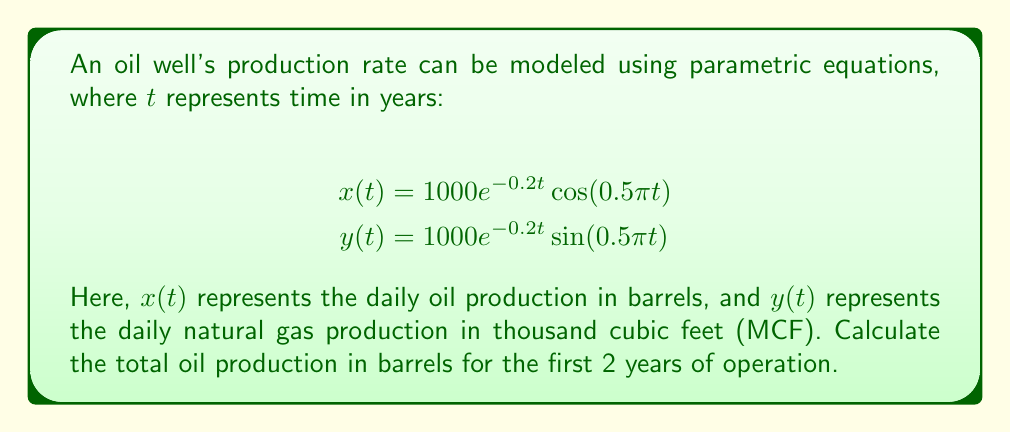Can you solve this math problem? To solve this problem, we need to integrate the oil production rate $x(t)$ over the time interval $[0, 2]$. The steps are as follows:

1) The total oil production is given by the definite integral:

   $$\int_0^2 x(t) dt = \int_0^2 1000e^{-0.2t}\cos(0.5\pi t) dt$$

2) This integral doesn't have a simple antiderivative, so we need to use numerical integration. We'll use the trapezoidal rule with a small step size for accuracy.

3) Let's use a step size of 0.01 years. The trapezoidal rule is given by:

   $$\int_a^b f(x) dx \approx \frac{h}{2}[f(a) + 2f(x_1) + 2f(x_2) + ... + 2f(x_{n-1}) + f(b)]$$

   where $h = (b-a)/n$, and $x_i = a + ih$ for $i = 1, 2, ..., n-1$

4) In our case, $a=0$, $b=2$, $n=200$, and $h=0.01$

5) Implementing this in a programming language or spreadsheet, we sum up all the values:

   $$\frac{0.01}{2}[1000 + 2(999.0 + 996.0 + ... + 375.1) + 373.9]$$

6) After calculation, the result is approximately 548,812.7 barrels.
Answer: The total oil production for the first 2 years is approximately 548,813 barrels. 